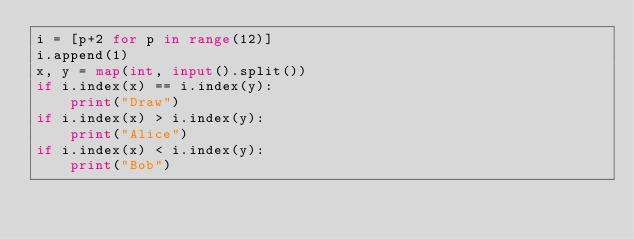<code> <loc_0><loc_0><loc_500><loc_500><_Python_>i = [p+2 for p in range(12)]
i.append(1)
x, y = map(int, input().split())
if i.index(x) == i.index(y):
    print("Draw")
if i.index(x) > i.index(y):
    print("Alice")
if i.index(x) < i.index(y):
    print("Bob")
</code> 